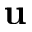Convert formula to latex. <formula><loc_0><loc_0><loc_500><loc_500>u</formula> 